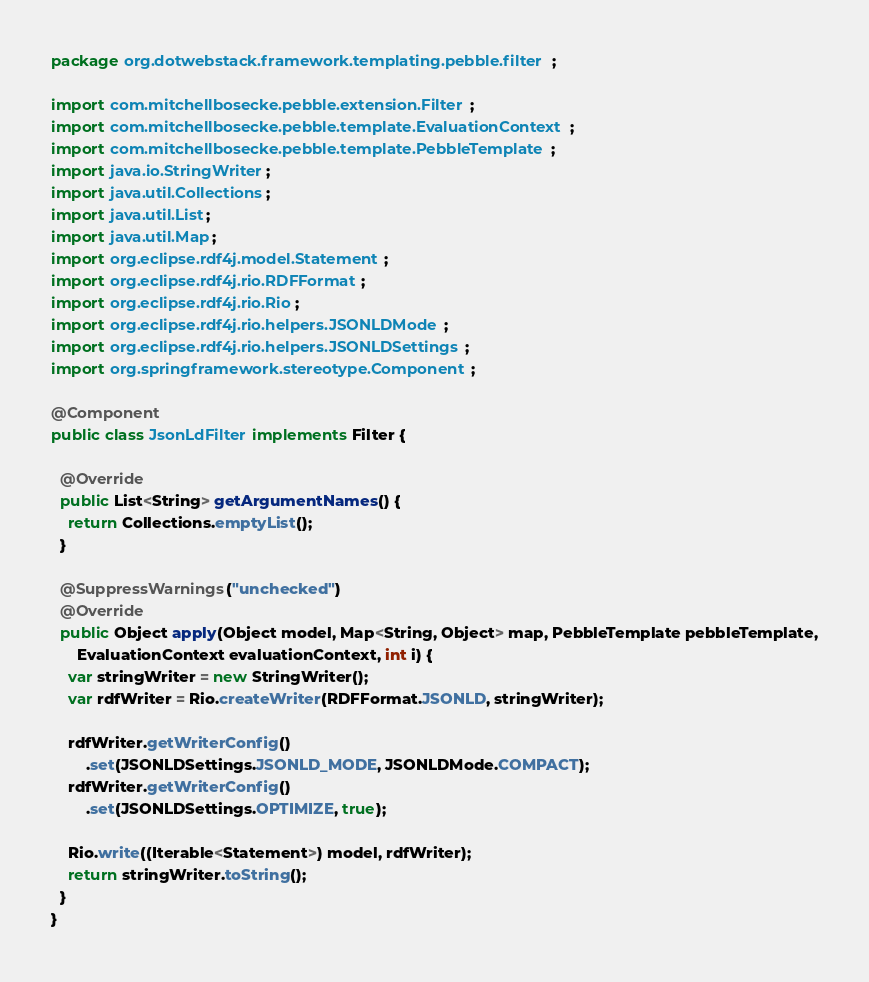Convert code to text. <code><loc_0><loc_0><loc_500><loc_500><_Java_>package org.dotwebstack.framework.templating.pebble.filter;

import com.mitchellbosecke.pebble.extension.Filter;
import com.mitchellbosecke.pebble.template.EvaluationContext;
import com.mitchellbosecke.pebble.template.PebbleTemplate;
import java.io.StringWriter;
import java.util.Collections;
import java.util.List;
import java.util.Map;
import org.eclipse.rdf4j.model.Statement;
import org.eclipse.rdf4j.rio.RDFFormat;
import org.eclipse.rdf4j.rio.Rio;
import org.eclipse.rdf4j.rio.helpers.JSONLDMode;
import org.eclipse.rdf4j.rio.helpers.JSONLDSettings;
import org.springframework.stereotype.Component;

@Component
public class JsonLdFilter implements Filter {

  @Override
  public List<String> getArgumentNames() {
    return Collections.emptyList();
  }

  @SuppressWarnings("unchecked")
  @Override
  public Object apply(Object model, Map<String, Object> map, PebbleTemplate pebbleTemplate,
      EvaluationContext evaluationContext, int i) {
    var stringWriter = new StringWriter();
    var rdfWriter = Rio.createWriter(RDFFormat.JSONLD, stringWriter);

    rdfWriter.getWriterConfig()
        .set(JSONLDSettings.JSONLD_MODE, JSONLDMode.COMPACT);
    rdfWriter.getWriterConfig()
        .set(JSONLDSettings.OPTIMIZE, true);

    Rio.write((Iterable<Statement>) model, rdfWriter);
    return stringWriter.toString();
  }
}
</code> 